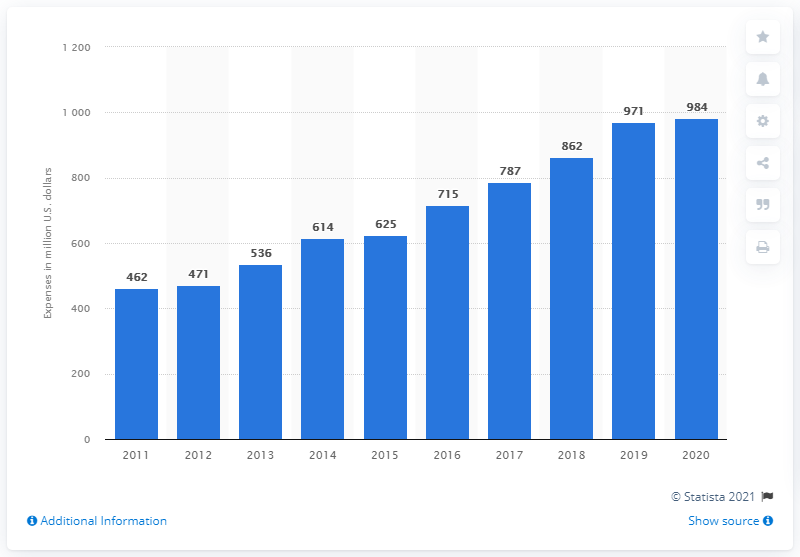What does the trend in the bar chart suggest about Stryker's investment in research and development over the past decade? The bar chart indicates that over the past decade, Stryker has shown a commitment to innovation and growth by progressively increasing its investment in research, development, and engineering. Starting at 462 million dollars in 2011, the investment peaked at 984 million dollars in 2020, suggesting a strategic emphasis on advancing their medical technologies. 